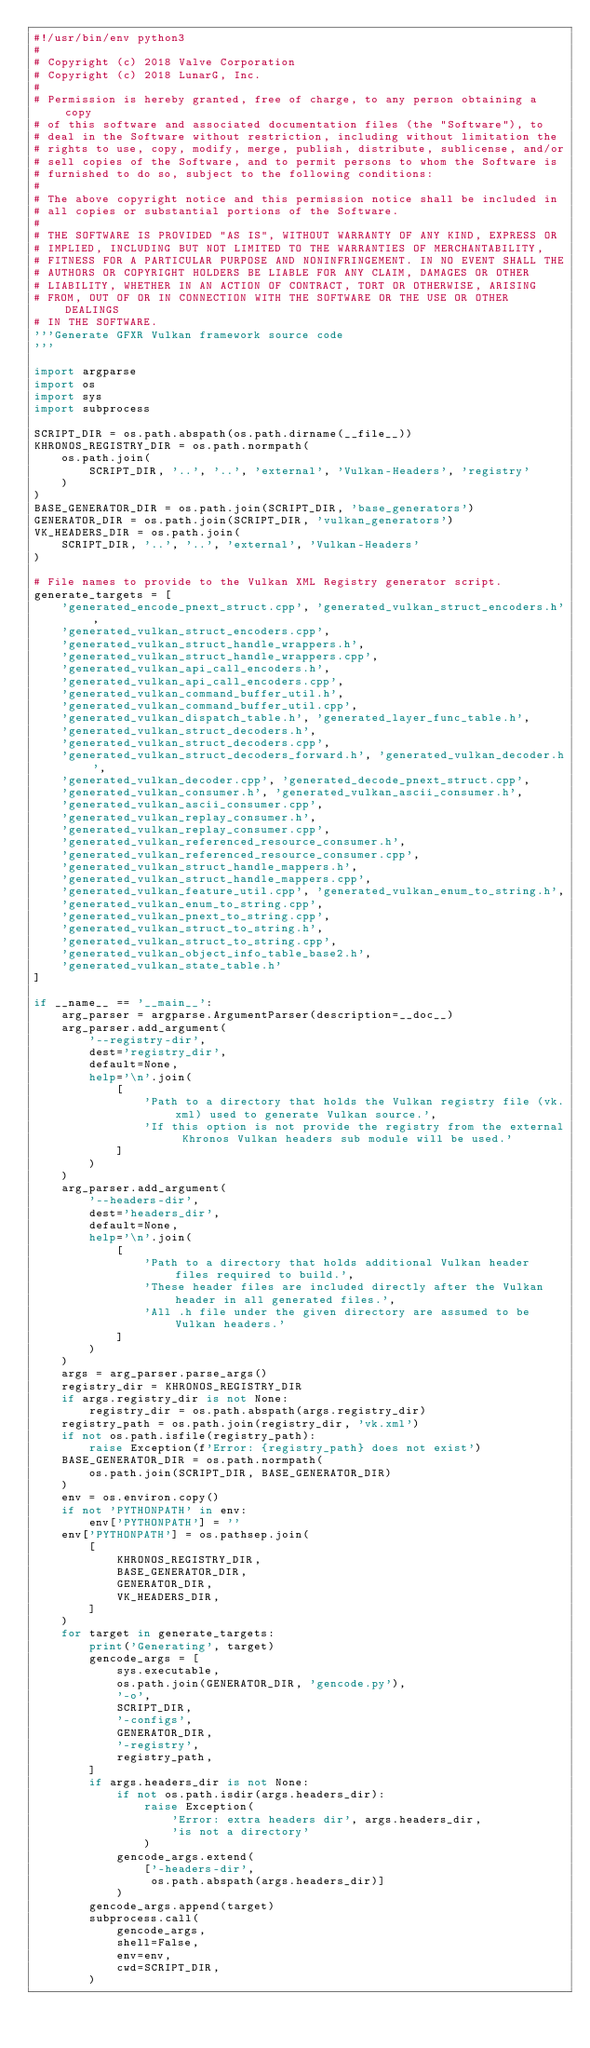<code> <loc_0><loc_0><loc_500><loc_500><_Python_>#!/usr/bin/env python3
#
# Copyright (c) 2018 Valve Corporation
# Copyright (c) 2018 LunarG, Inc.
#
# Permission is hereby granted, free of charge, to any person obtaining a copy
# of this software and associated documentation files (the "Software"), to
# deal in the Software without restriction, including without limitation the
# rights to use, copy, modify, merge, publish, distribute, sublicense, and/or
# sell copies of the Software, and to permit persons to whom the Software is
# furnished to do so, subject to the following conditions:
#
# The above copyright notice and this permission notice shall be included in
# all copies or substantial portions of the Software.
#
# THE SOFTWARE IS PROVIDED "AS IS", WITHOUT WARRANTY OF ANY KIND, EXPRESS OR
# IMPLIED, INCLUDING BUT NOT LIMITED TO THE WARRANTIES OF MERCHANTABILITY,
# FITNESS FOR A PARTICULAR PURPOSE AND NONINFRINGEMENT. IN NO EVENT SHALL THE
# AUTHORS OR COPYRIGHT HOLDERS BE LIABLE FOR ANY CLAIM, DAMAGES OR OTHER
# LIABILITY, WHETHER IN AN ACTION OF CONTRACT, TORT OR OTHERWISE, ARISING
# FROM, OUT OF OR IN CONNECTION WITH THE SOFTWARE OR THE USE OR OTHER DEALINGS
# IN THE SOFTWARE.
'''Generate GFXR Vulkan framework source code
'''

import argparse
import os
import sys
import subprocess

SCRIPT_DIR = os.path.abspath(os.path.dirname(__file__))
KHRONOS_REGISTRY_DIR = os.path.normpath(
    os.path.join(
        SCRIPT_DIR, '..', '..', 'external', 'Vulkan-Headers', 'registry'
    )
)
BASE_GENERATOR_DIR = os.path.join(SCRIPT_DIR, 'base_generators')
GENERATOR_DIR = os.path.join(SCRIPT_DIR, 'vulkan_generators')
VK_HEADERS_DIR = os.path.join(
    SCRIPT_DIR, '..', '..', 'external', 'Vulkan-Headers'
)

# File names to provide to the Vulkan XML Registry generator script.
generate_targets = [
    'generated_encode_pnext_struct.cpp', 'generated_vulkan_struct_encoders.h',
    'generated_vulkan_struct_encoders.cpp',
    'generated_vulkan_struct_handle_wrappers.h',
    'generated_vulkan_struct_handle_wrappers.cpp',
    'generated_vulkan_api_call_encoders.h',
    'generated_vulkan_api_call_encoders.cpp',
    'generated_vulkan_command_buffer_util.h',
    'generated_vulkan_command_buffer_util.cpp',
    'generated_vulkan_dispatch_table.h', 'generated_layer_func_table.h',
    'generated_vulkan_struct_decoders.h',
    'generated_vulkan_struct_decoders.cpp',
    'generated_vulkan_struct_decoders_forward.h', 'generated_vulkan_decoder.h',
    'generated_vulkan_decoder.cpp', 'generated_decode_pnext_struct.cpp',
    'generated_vulkan_consumer.h', 'generated_vulkan_ascii_consumer.h',
    'generated_vulkan_ascii_consumer.cpp',
    'generated_vulkan_replay_consumer.h',
    'generated_vulkan_replay_consumer.cpp',
    'generated_vulkan_referenced_resource_consumer.h',
    'generated_vulkan_referenced_resource_consumer.cpp',
    'generated_vulkan_struct_handle_mappers.h',
    'generated_vulkan_struct_handle_mappers.cpp',
    'generated_vulkan_feature_util.cpp', 'generated_vulkan_enum_to_string.h',
    'generated_vulkan_enum_to_string.cpp',
    'generated_vulkan_pnext_to_string.cpp',
    'generated_vulkan_struct_to_string.h',
    'generated_vulkan_struct_to_string.cpp',
    'generated_vulkan_object_info_table_base2.h',
    'generated_vulkan_state_table.h'
]

if __name__ == '__main__':
    arg_parser = argparse.ArgumentParser(description=__doc__)
    arg_parser.add_argument(
        '--registry-dir',
        dest='registry_dir',
        default=None,
        help='\n'.join(
            [
                'Path to a directory that holds the Vulkan registry file (vk.xml) used to generate Vulkan source.',
                'If this option is not provide the registry from the external Khronos Vulkan headers sub module will be used.'
            ]
        )
    )
    arg_parser.add_argument(
        '--headers-dir',
        dest='headers_dir',
        default=None,
        help='\n'.join(
            [
                'Path to a directory that holds additional Vulkan header files required to build.',
                'These header files are included directly after the Vulkan header in all generated files.',
                'All .h file under the given directory are assumed to be Vulkan headers.'
            ]
        )
    )
    args = arg_parser.parse_args()
    registry_dir = KHRONOS_REGISTRY_DIR
    if args.registry_dir is not None:
        registry_dir = os.path.abspath(args.registry_dir)
    registry_path = os.path.join(registry_dir, 'vk.xml')
    if not os.path.isfile(registry_path):
        raise Exception(f'Error: {registry_path} does not exist')
    BASE_GENERATOR_DIR = os.path.normpath(
        os.path.join(SCRIPT_DIR, BASE_GENERATOR_DIR)
    )
    env = os.environ.copy()
    if not 'PYTHONPATH' in env:
        env['PYTHONPATH'] = ''
    env['PYTHONPATH'] = os.pathsep.join(
        [
            KHRONOS_REGISTRY_DIR,
            BASE_GENERATOR_DIR,
            GENERATOR_DIR,
            VK_HEADERS_DIR,
        ]
    )
    for target in generate_targets:
        print('Generating', target)
        gencode_args = [
            sys.executable,
            os.path.join(GENERATOR_DIR, 'gencode.py'),
            '-o',
            SCRIPT_DIR,
            '-configs',
            GENERATOR_DIR,
            '-registry',
            registry_path,
        ]
        if args.headers_dir is not None:
            if not os.path.isdir(args.headers_dir):
                raise Exception(
                    'Error: extra headers dir', args.headers_dir,
                    'is not a directory'
                )
            gencode_args.extend(
                ['-headers-dir',
                 os.path.abspath(args.headers_dir)]
            )
        gencode_args.append(target)
        subprocess.call(
            gencode_args,
            shell=False,
            env=env,
            cwd=SCRIPT_DIR,
        )
</code> 